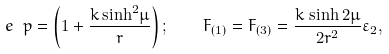<formula> <loc_0><loc_0><loc_500><loc_500>e ^ { \ } p = \left ( 1 + \frac { k \, { \sinh } ^ { 2 } \mu } { r } \right ) ; \quad F _ { ( 1 ) } = F _ { ( 3 ) } = \frac { k \, \sinh { 2 \mu } } { 2 r ^ { 2 } } { \varepsilon } _ { 2 } ,</formula> 